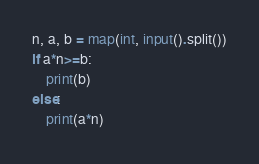<code> <loc_0><loc_0><loc_500><loc_500><_Python_>n, a, b = map(int, input().split())
if a*n>=b:
    print(b)
else:
    print(a*n)</code> 